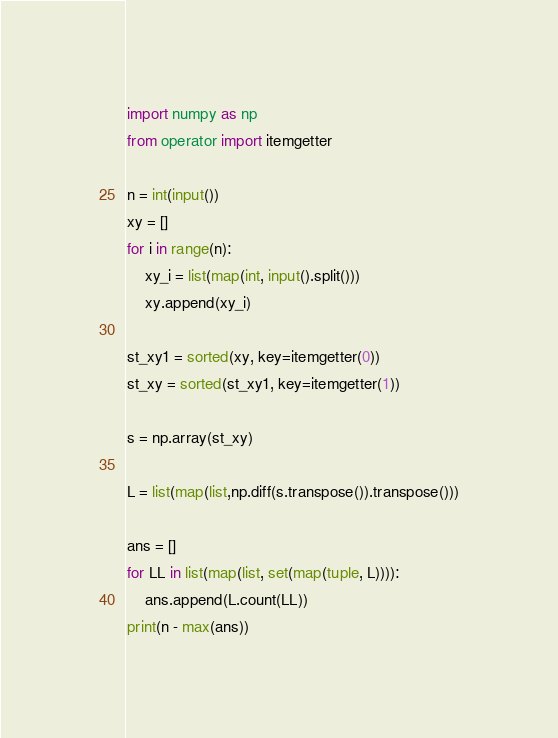Convert code to text. <code><loc_0><loc_0><loc_500><loc_500><_Python_>import numpy as np
from operator import itemgetter

n = int(input())
xy = []
for i in range(n):
    xy_i = list(map(int, input().split()))
    xy.append(xy_i)

st_xy1 = sorted(xy, key=itemgetter(0))
st_xy = sorted(st_xy1, key=itemgetter(1))

s = np.array(st_xy)

L = list(map(list,np.diff(s.transpose()).transpose()))

ans = []
for LL in list(map(list, set(map(tuple, L)))):
    ans.append(L.count(LL))
print(n - max(ans))</code> 